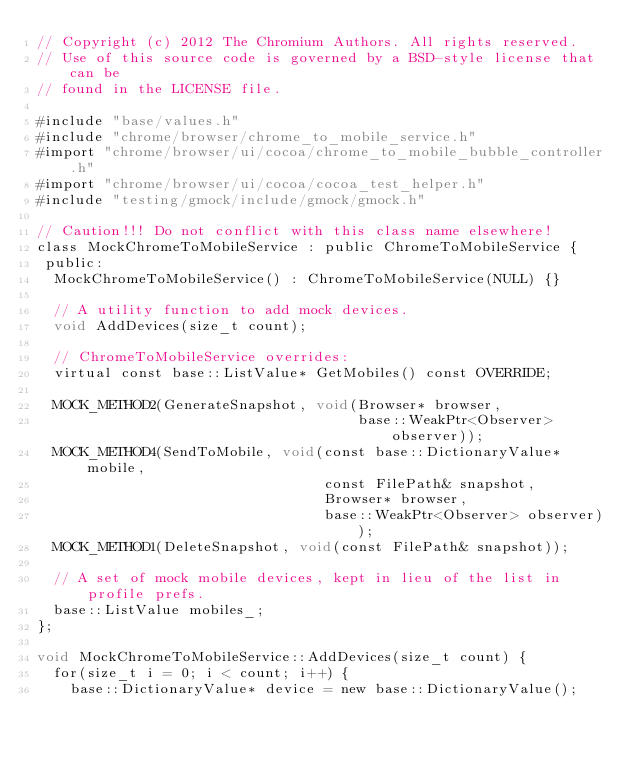Convert code to text. <code><loc_0><loc_0><loc_500><loc_500><_ObjectiveC_>// Copyright (c) 2012 The Chromium Authors. All rights reserved.
// Use of this source code is governed by a BSD-style license that can be
// found in the LICENSE file.

#include "base/values.h"
#include "chrome/browser/chrome_to_mobile_service.h"
#import "chrome/browser/ui/cocoa/chrome_to_mobile_bubble_controller.h"
#import "chrome/browser/ui/cocoa/cocoa_test_helper.h"
#include "testing/gmock/include/gmock/gmock.h"

// Caution!!! Do not conflict with this class name elsewhere!
class MockChromeToMobileService : public ChromeToMobileService {
 public:
  MockChromeToMobileService() : ChromeToMobileService(NULL) {}

  // A utility function to add mock devices.
  void AddDevices(size_t count);

  // ChromeToMobileService overrides:
  virtual const base::ListValue* GetMobiles() const OVERRIDE;

  MOCK_METHOD2(GenerateSnapshot, void(Browser* browser,
                                      base::WeakPtr<Observer> observer));
  MOCK_METHOD4(SendToMobile, void(const base::DictionaryValue* mobile,
                                  const FilePath& snapshot,
                                  Browser* browser,
                                  base::WeakPtr<Observer> observer));
  MOCK_METHOD1(DeleteSnapshot, void(const FilePath& snapshot));

  // A set of mock mobile devices, kept in lieu of the list in profile prefs.
  base::ListValue mobiles_;
};

void MockChromeToMobileService::AddDevices(size_t count) {
  for(size_t i = 0; i < count; i++) {
    base::DictionaryValue* device = new base::DictionaryValue();</code> 